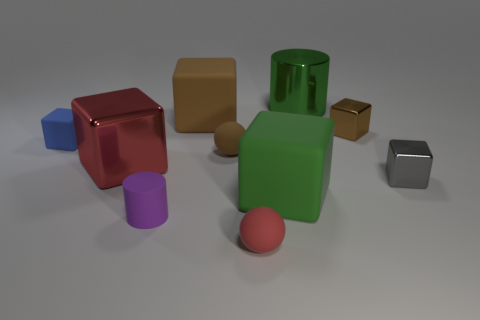Are there more large green metallic cylinders that are right of the tiny red sphere than small brown rubber things that are on the right side of the metal cylinder?
Your answer should be very brief. Yes. What material is the brown object that is the same size as the green rubber block?
Provide a short and direct response. Rubber. How many small things are green cubes or blue rubber things?
Offer a terse response. 1. Does the blue thing have the same shape as the red metallic object?
Give a very brief answer. Yes. How many tiny cubes are both left of the gray cube and in front of the blue thing?
Give a very brief answer. 0. Are there any other things of the same color as the large cylinder?
Your answer should be compact. Yes. What is the shape of the red object that is made of the same material as the brown ball?
Provide a succinct answer. Sphere. Does the green metal cylinder have the same size as the purple matte cylinder?
Offer a very short reply. No. Are the green thing that is behind the tiny blue rubber object and the blue cube made of the same material?
Ensure brevity in your answer.  No. Are there any other things that are the same material as the big brown thing?
Keep it short and to the point. Yes. 